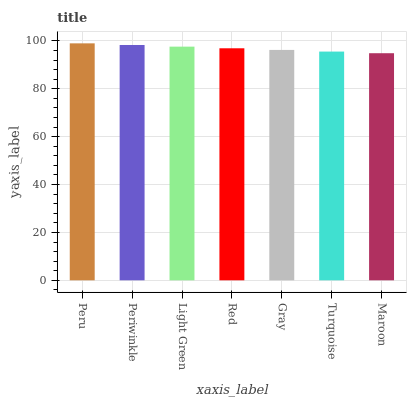Is Maroon the minimum?
Answer yes or no. Yes. Is Peru the maximum?
Answer yes or no. Yes. Is Periwinkle the minimum?
Answer yes or no. No. Is Periwinkle the maximum?
Answer yes or no. No. Is Peru greater than Periwinkle?
Answer yes or no. Yes. Is Periwinkle less than Peru?
Answer yes or no. Yes. Is Periwinkle greater than Peru?
Answer yes or no. No. Is Peru less than Periwinkle?
Answer yes or no. No. Is Red the high median?
Answer yes or no. Yes. Is Red the low median?
Answer yes or no. Yes. Is Light Green the high median?
Answer yes or no. No. Is Periwinkle the low median?
Answer yes or no. No. 